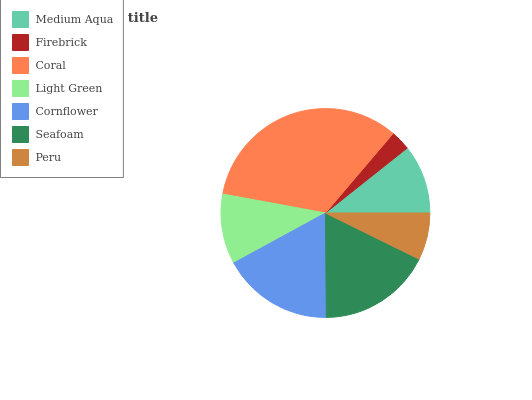Is Firebrick the minimum?
Answer yes or no. Yes. Is Coral the maximum?
Answer yes or no. Yes. Is Coral the minimum?
Answer yes or no. No. Is Firebrick the maximum?
Answer yes or no. No. Is Coral greater than Firebrick?
Answer yes or no. Yes. Is Firebrick less than Coral?
Answer yes or no. Yes. Is Firebrick greater than Coral?
Answer yes or no. No. Is Coral less than Firebrick?
Answer yes or no. No. Is Light Green the high median?
Answer yes or no. Yes. Is Light Green the low median?
Answer yes or no. Yes. Is Seafoam the high median?
Answer yes or no. No. Is Medium Aqua the low median?
Answer yes or no. No. 